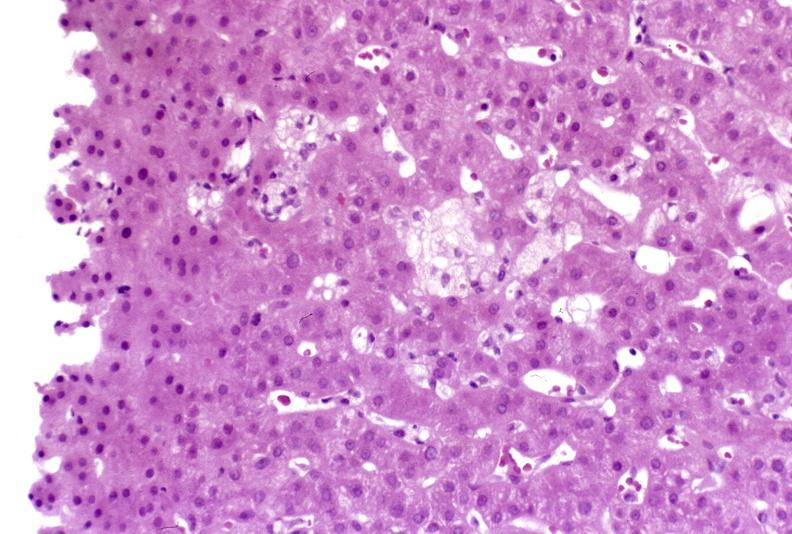s hepatobiliary present?
Answer the question using a single word or phrase. Yes 